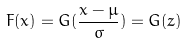<formula> <loc_0><loc_0><loc_500><loc_500>F ( x ) = G ( \frac { x - \mu } { \sigma } ) = G ( z )</formula> 